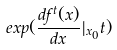<formula> <loc_0><loc_0><loc_500><loc_500>e x p ( \frac { d f ^ { t } ( x ) } { d x } | _ { x _ { 0 } } t )</formula> 